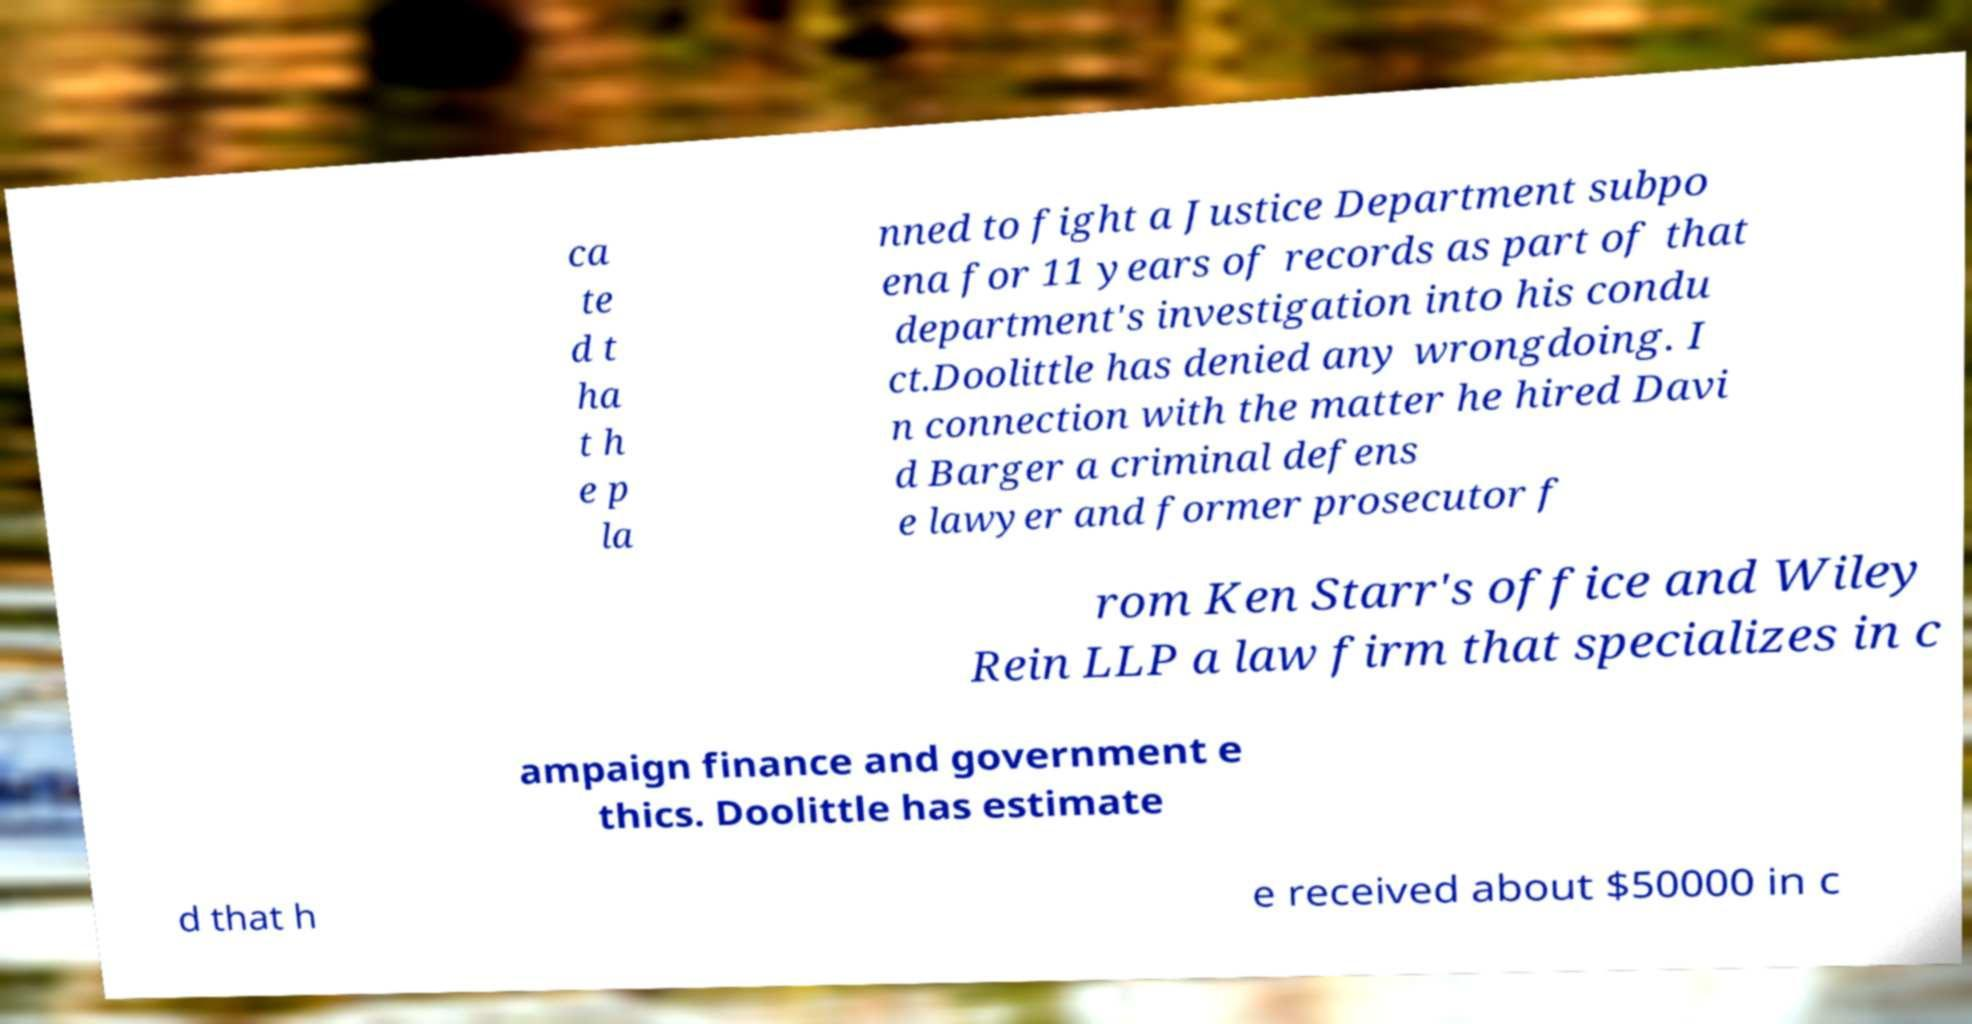Can you accurately transcribe the text from the provided image for me? ca te d t ha t h e p la nned to fight a Justice Department subpo ena for 11 years of records as part of that department's investigation into his condu ct.Doolittle has denied any wrongdoing. I n connection with the matter he hired Davi d Barger a criminal defens e lawyer and former prosecutor f rom Ken Starr's office and Wiley Rein LLP a law firm that specializes in c ampaign finance and government e thics. Doolittle has estimate d that h e received about $50000 in c 